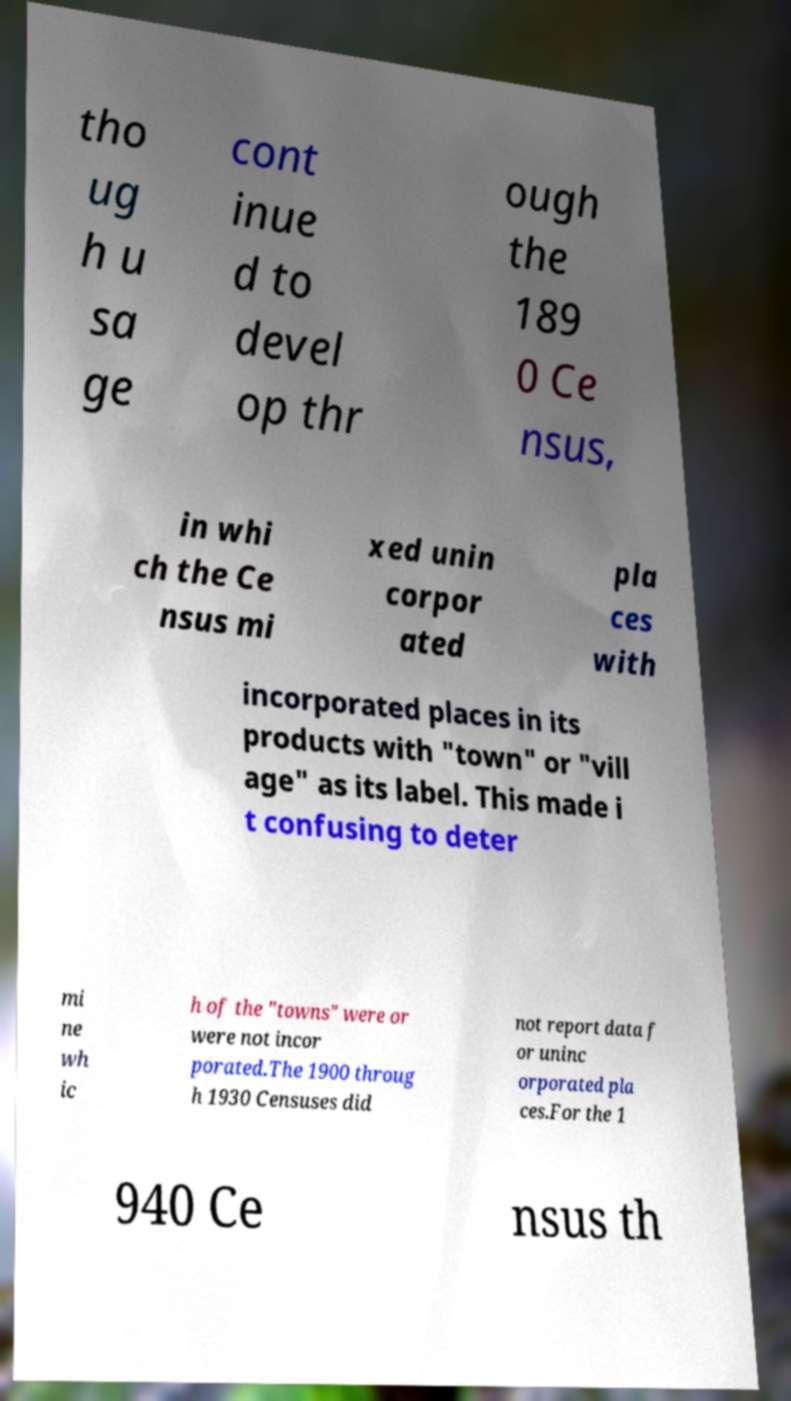For documentation purposes, I need the text within this image transcribed. Could you provide that? tho ug h u sa ge cont inue d to devel op thr ough the 189 0 Ce nsus, in whi ch the Ce nsus mi xed unin corpor ated pla ces with incorporated places in its products with "town" or "vill age" as its label. This made i t confusing to deter mi ne wh ic h of the "towns" were or were not incor porated.The 1900 throug h 1930 Censuses did not report data f or uninc orporated pla ces.For the 1 940 Ce nsus th 